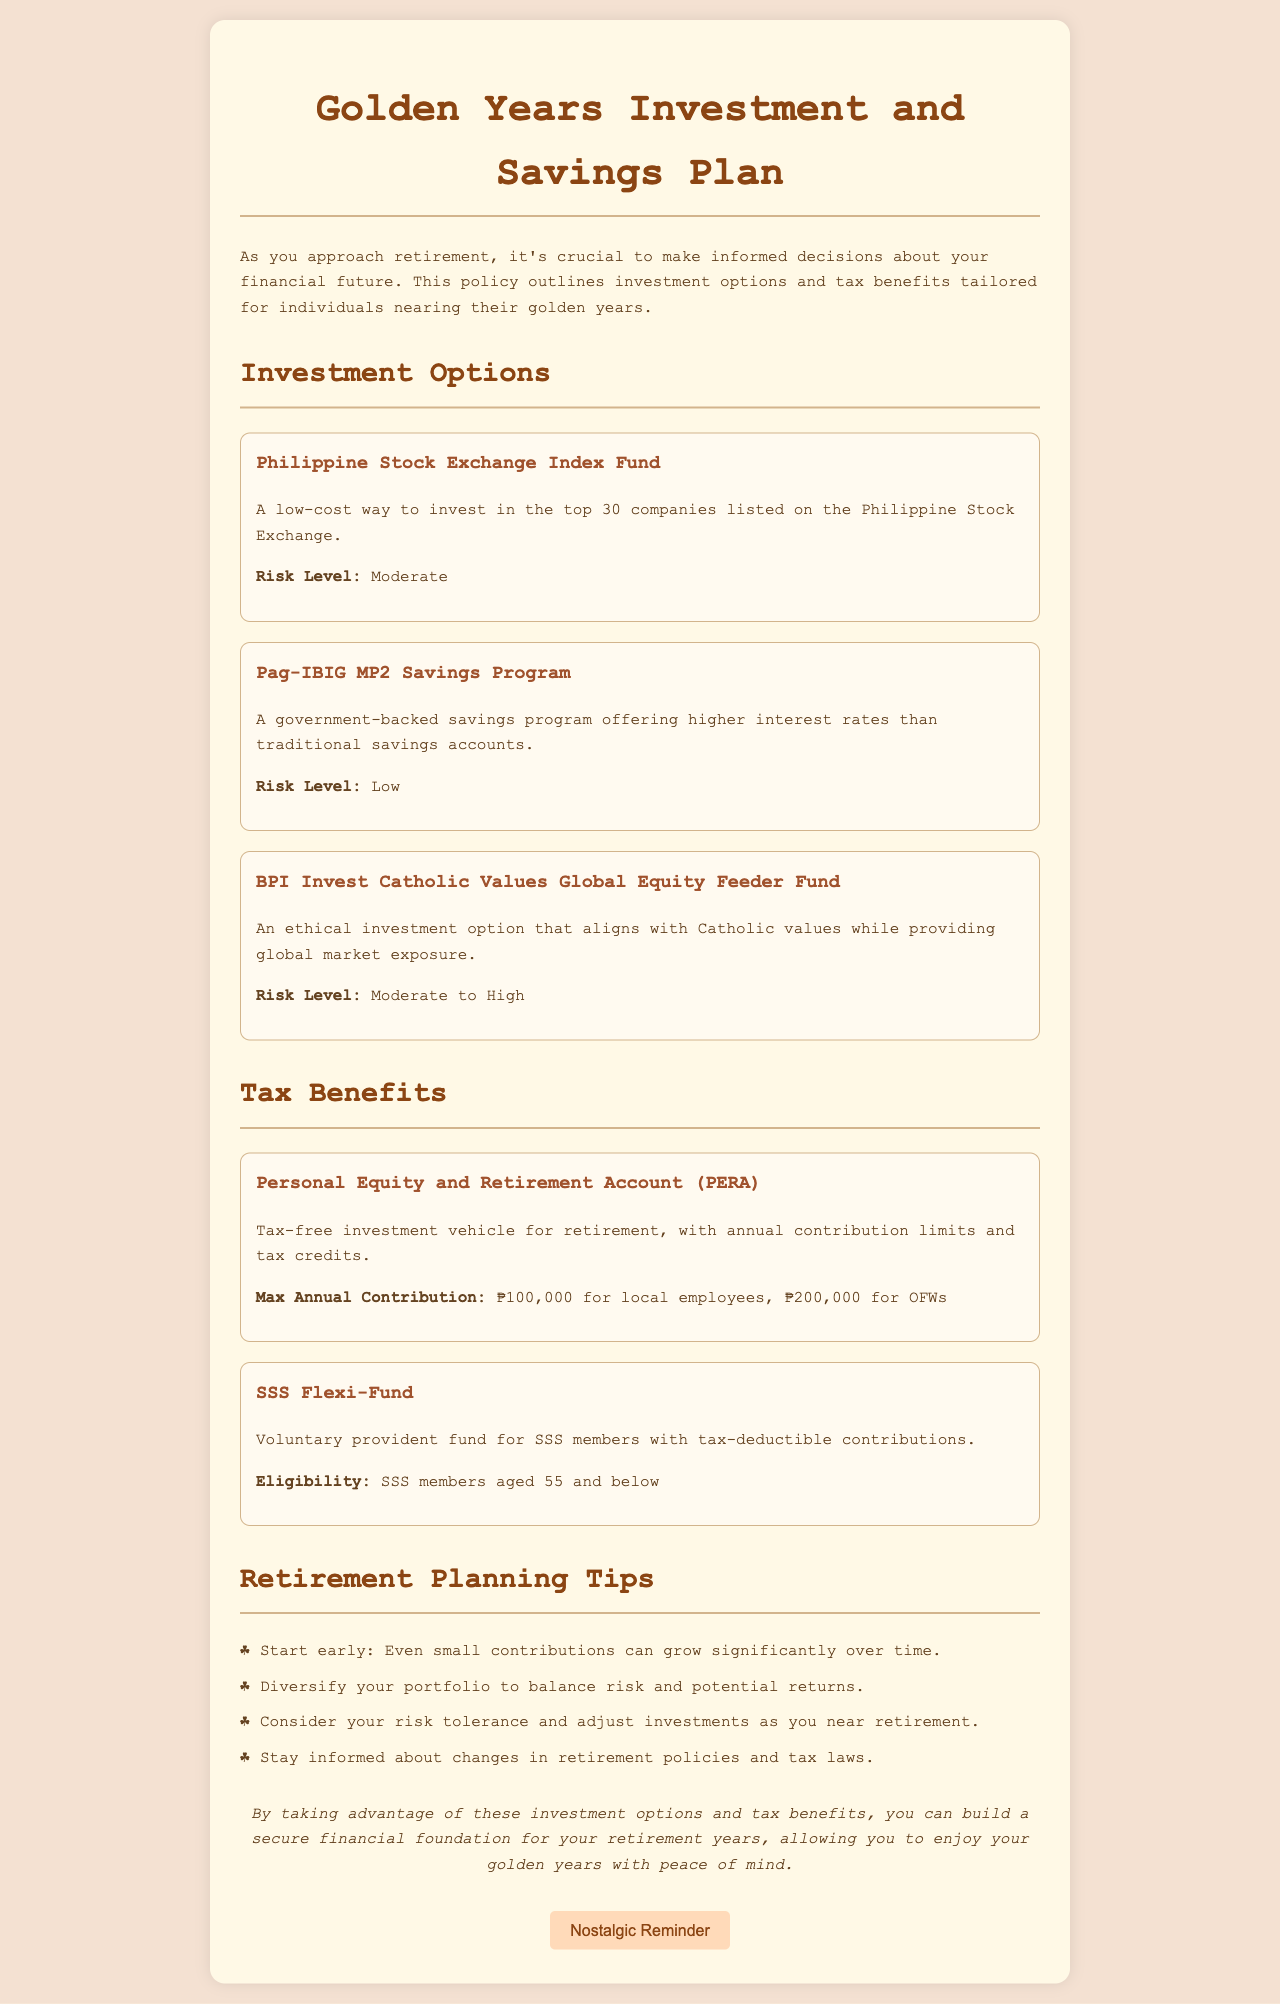What are the top 30 companies listed on? The investment option refers to the Philippine Stock Exchange, which includes the top 30 companies listed on it.
Answer: Philippine Stock Exchange What savings program offers higher interest rates than traditional savings accounts? This refers specifically to the Pag-IBIG MP2 Savings Program outlined in the document.
Answer: Pag-IBIG MP2 Savings Program What is the maximum annual contribution for local employees under PERA? The document specifies that the max annual contribution for local employees is ₱100,000.
Answer: ₱100,000 How many investment options are listed in the document? There are three investment options detailed in the investment options section of the document.
Answer: Three What is the risk level of the BPI Invest Catholic Values Global Equity Feeder Fund? The document categorizes the risk level of this investment option as Moderate to High.
Answer: Moderate to High Which tax benefit is specifically available for SSS members aged 55 and below? This specific tax benefit mentioned in the document is the SSS Flexi-Fund.
Answer: SSS Flexi-Fund What should individuals do to balance risk and potential returns? The document advises diversifying your portfolio for this purpose.
Answer: Diversify your portfolio How does the document recommend contributing to retirement planning? The document specifies starting early as a recommended action for retirement planning.
Answer: Start early 